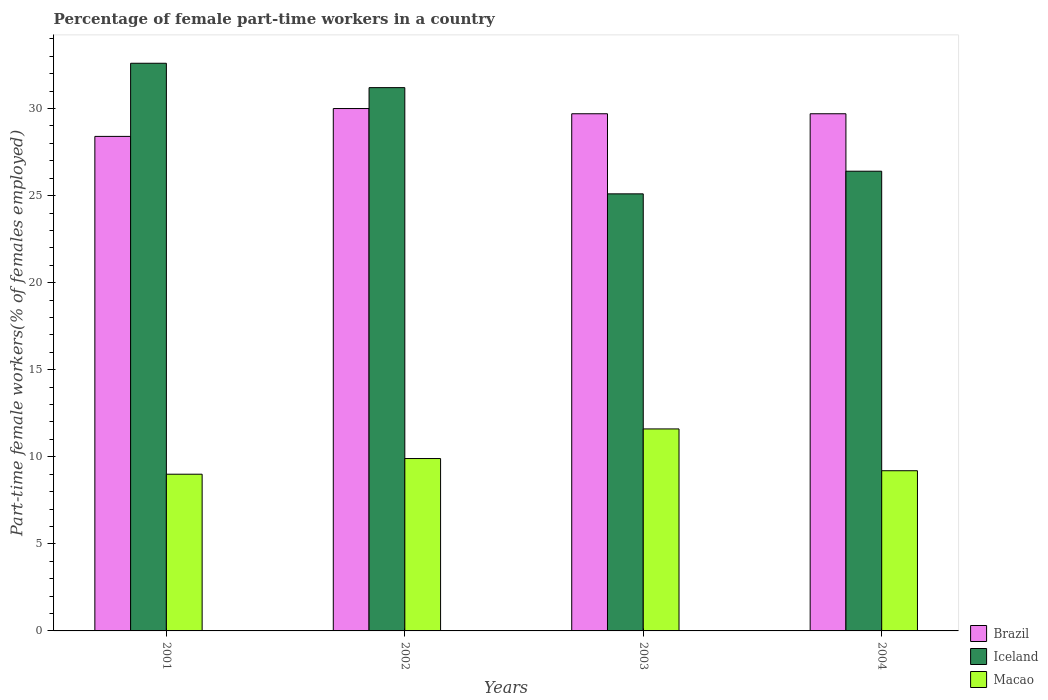How many groups of bars are there?
Make the answer very short. 4. Are the number of bars per tick equal to the number of legend labels?
Your answer should be compact. Yes. Are the number of bars on each tick of the X-axis equal?
Give a very brief answer. Yes. How many bars are there on the 1st tick from the left?
Provide a succinct answer. 3. What is the label of the 3rd group of bars from the left?
Keep it short and to the point. 2003. What is the percentage of female part-time workers in Macao in 2002?
Your response must be concise. 9.9. Across all years, what is the maximum percentage of female part-time workers in Iceland?
Your response must be concise. 32.6. Across all years, what is the minimum percentage of female part-time workers in Brazil?
Your answer should be compact. 28.4. In which year was the percentage of female part-time workers in Iceland maximum?
Keep it short and to the point. 2001. What is the total percentage of female part-time workers in Macao in the graph?
Give a very brief answer. 39.7. What is the difference between the percentage of female part-time workers in Macao in 2002 and the percentage of female part-time workers in Iceland in 2004?
Offer a terse response. -16.5. What is the average percentage of female part-time workers in Iceland per year?
Your answer should be very brief. 28.82. In the year 2003, what is the difference between the percentage of female part-time workers in Brazil and percentage of female part-time workers in Macao?
Keep it short and to the point. 18.1. In how many years, is the percentage of female part-time workers in Iceland greater than 24 %?
Provide a succinct answer. 4. What is the ratio of the percentage of female part-time workers in Brazil in 2002 to that in 2004?
Provide a succinct answer. 1.01. Is the percentage of female part-time workers in Brazil in 2002 less than that in 2004?
Your response must be concise. No. What is the difference between the highest and the second highest percentage of female part-time workers in Brazil?
Your answer should be compact. 0.3. What is the difference between the highest and the lowest percentage of female part-time workers in Brazil?
Give a very brief answer. 1.6. Is the sum of the percentage of female part-time workers in Brazil in 2002 and 2003 greater than the maximum percentage of female part-time workers in Iceland across all years?
Ensure brevity in your answer.  Yes. What does the 3rd bar from the left in 2001 represents?
Provide a succinct answer. Macao. What does the 1st bar from the right in 2001 represents?
Ensure brevity in your answer.  Macao. How many years are there in the graph?
Your response must be concise. 4. What is the difference between two consecutive major ticks on the Y-axis?
Keep it short and to the point. 5. Does the graph contain any zero values?
Your answer should be very brief. No. How many legend labels are there?
Offer a very short reply. 3. How are the legend labels stacked?
Keep it short and to the point. Vertical. What is the title of the graph?
Your answer should be very brief. Percentage of female part-time workers in a country. What is the label or title of the Y-axis?
Give a very brief answer. Part-time female workers(% of females employed). What is the Part-time female workers(% of females employed) in Brazil in 2001?
Your answer should be very brief. 28.4. What is the Part-time female workers(% of females employed) of Iceland in 2001?
Offer a terse response. 32.6. What is the Part-time female workers(% of females employed) of Macao in 2001?
Provide a succinct answer. 9. What is the Part-time female workers(% of females employed) of Brazil in 2002?
Offer a very short reply. 30. What is the Part-time female workers(% of females employed) in Iceland in 2002?
Offer a very short reply. 31.2. What is the Part-time female workers(% of females employed) of Macao in 2002?
Keep it short and to the point. 9.9. What is the Part-time female workers(% of females employed) of Brazil in 2003?
Keep it short and to the point. 29.7. What is the Part-time female workers(% of females employed) in Iceland in 2003?
Provide a short and direct response. 25.1. What is the Part-time female workers(% of females employed) of Macao in 2003?
Offer a very short reply. 11.6. What is the Part-time female workers(% of females employed) in Brazil in 2004?
Offer a terse response. 29.7. What is the Part-time female workers(% of females employed) in Iceland in 2004?
Make the answer very short. 26.4. What is the Part-time female workers(% of females employed) of Macao in 2004?
Keep it short and to the point. 9.2. Across all years, what is the maximum Part-time female workers(% of females employed) in Brazil?
Keep it short and to the point. 30. Across all years, what is the maximum Part-time female workers(% of females employed) in Iceland?
Your answer should be compact. 32.6. Across all years, what is the maximum Part-time female workers(% of females employed) of Macao?
Make the answer very short. 11.6. Across all years, what is the minimum Part-time female workers(% of females employed) of Brazil?
Ensure brevity in your answer.  28.4. Across all years, what is the minimum Part-time female workers(% of females employed) in Iceland?
Keep it short and to the point. 25.1. What is the total Part-time female workers(% of females employed) of Brazil in the graph?
Make the answer very short. 117.8. What is the total Part-time female workers(% of females employed) of Iceland in the graph?
Offer a terse response. 115.3. What is the total Part-time female workers(% of females employed) of Macao in the graph?
Your answer should be compact. 39.7. What is the difference between the Part-time female workers(% of females employed) of Brazil in 2001 and that in 2002?
Your answer should be compact. -1.6. What is the difference between the Part-time female workers(% of females employed) in Iceland in 2001 and that in 2002?
Your answer should be very brief. 1.4. What is the difference between the Part-time female workers(% of females employed) in Macao in 2001 and that in 2002?
Keep it short and to the point. -0.9. What is the difference between the Part-time female workers(% of females employed) of Brazil in 2001 and that in 2003?
Make the answer very short. -1.3. What is the difference between the Part-time female workers(% of females employed) in Iceland in 2001 and that in 2003?
Give a very brief answer. 7.5. What is the difference between the Part-time female workers(% of females employed) in Brazil in 2001 and that in 2004?
Make the answer very short. -1.3. What is the difference between the Part-time female workers(% of females employed) in Iceland in 2001 and that in 2004?
Ensure brevity in your answer.  6.2. What is the difference between the Part-time female workers(% of females employed) of Macao in 2001 and that in 2004?
Your answer should be compact. -0.2. What is the difference between the Part-time female workers(% of females employed) in Brazil in 2002 and that in 2003?
Your response must be concise. 0.3. What is the difference between the Part-time female workers(% of females employed) of Iceland in 2002 and that in 2003?
Provide a succinct answer. 6.1. What is the difference between the Part-time female workers(% of females employed) in Macao in 2002 and that in 2003?
Your answer should be very brief. -1.7. What is the difference between the Part-time female workers(% of females employed) in Brazil in 2003 and that in 2004?
Give a very brief answer. 0. What is the difference between the Part-time female workers(% of females employed) in Macao in 2003 and that in 2004?
Make the answer very short. 2.4. What is the difference between the Part-time female workers(% of females employed) in Brazil in 2001 and the Part-time female workers(% of females employed) in Iceland in 2002?
Keep it short and to the point. -2.8. What is the difference between the Part-time female workers(% of females employed) of Iceland in 2001 and the Part-time female workers(% of females employed) of Macao in 2002?
Ensure brevity in your answer.  22.7. What is the difference between the Part-time female workers(% of females employed) in Brazil in 2001 and the Part-time female workers(% of females employed) in Iceland in 2003?
Give a very brief answer. 3.3. What is the difference between the Part-time female workers(% of females employed) in Brazil in 2001 and the Part-time female workers(% of females employed) in Macao in 2003?
Your response must be concise. 16.8. What is the difference between the Part-time female workers(% of females employed) in Brazil in 2001 and the Part-time female workers(% of females employed) in Iceland in 2004?
Provide a short and direct response. 2. What is the difference between the Part-time female workers(% of females employed) in Brazil in 2001 and the Part-time female workers(% of females employed) in Macao in 2004?
Your answer should be very brief. 19.2. What is the difference between the Part-time female workers(% of females employed) of Iceland in 2001 and the Part-time female workers(% of females employed) of Macao in 2004?
Offer a very short reply. 23.4. What is the difference between the Part-time female workers(% of females employed) in Brazil in 2002 and the Part-time female workers(% of females employed) in Iceland in 2003?
Offer a very short reply. 4.9. What is the difference between the Part-time female workers(% of females employed) in Brazil in 2002 and the Part-time female workers(% of females employed) in Macao in 2003?
Keep it short and to the point. 18.4. What is the difference between the Part-time female workers(% of females employed) of Iceland in 2002 and the Part-time female workers(% of females employed) of Macao in 2003?
Your response must be concise. 19.6. What is the difference between the Part-time female workers(% of females employed) of Brazil in 2002 and the Part-time female workers(% of females employed) of Macao in 2004?
Your answer should be very brief. 20.8. What is the difference between the Part-time female workers(% of females employed) in Iceland in 2002 and the Part-time female workers(% of females employed) in Macao in 2004?
Your answer should be compact. 22. What is the difference between the Part-time female workers(% of females employed) of Brazil in 2003 and the Part-time female workers(% of females employed) of Macao in 2004?
Provide a short and direct response. 20.5. What is the difference between the Part-time female workers(% of females employed) of Iceland in 2003 and the Part-time female workers(% of females employed) of Macao in 2004?
Provide a succinct answer. 15.9. What is the average Part-time female workers(% of females employed) of Brazil per year?
Your response must be concise. 29.45. What is the average Part-time female workers(% of females employed) of Iceland per year?
Your answer should be compact. 28.82. What is the average Part-time female workers(% of females employed) of Macao per year?
Your answer should be compact. 9.93. In the year 2001, what is the difference between the Part-time female workers(% of females employed) in Iceland and Part-time female workers(% of females employed) in Macao?
Ensure brevity in your answer.  23.6. In the year 2002, what is the difference between the Part-time female workers(% of females employed) in Brazil and Part-time female workers(% of females employed) in Macao?
Provide a succinct answer. 20.1. In the year 2002, what is the difference between the Part-time female workers(% of females employed) in Iceland and Part-time female workers(% of females employed) in Macao?
Your answer should be very brief. 21.3. In the year 2003, what is the difference between the Part-time female workers(% of females employed) of Brazil and Part-time female workers(% of females employed) of Macao?
Offer a very short reply. 18.1. In the year 2003, what is the difference between the Part-time female workers(% of females employed) of Iceland and Part-time female workers(% of females employed) of Macao?
Your answer should be compact. 13.5. In the year 2004, what is the difference between the Part-time female workers(% of females employed) in Brazil and Part-time female workers(% of females employed) in Macao?
Keep it short and to the point. 20.5. In the year 2004, what is the difference between the Part-time female workers(% of females employed) of Iceland and Part-time female workers(% of females employed) of Macao?
Your response must be concise. 17.2. What is the ratio of the Part-time female workers(% of females employed) of Brazil in 2001 to that in 2002?
Give a very brief answer. 0.95. What is the ratio of the Part-time female workers(% of females employed) of Iceland in 2001 to that in 2002?
Your answer should be compact. 1.04. What is the ratio of the Part-time female workers(% of females employed) in Macao in 2001 to that in 2002?
Provide a short and direct response. 0.91. What is the ratio of the Part-time female workers(% of females employed) of Brazil in 2001 to that in 2003?
Ensure brevity in your answer.  0.96. What is the ratio of the Part-time female workers(% of females employed) of Iceland in 2001 to that in 2003?
Provide a short and direct response. 1.3. What is the ratio of the Part-time female workers(% of females employed) of Macao in 2001 to that in 2003?
Offer a very short reply. 0.78. What is the ratio of the Part-time female workers(% of females employed) in Brazil in 2001 to that in 2004?
Offer a terse response. 0.96. What is the ratio of the Part-time female workers(% of females employed) of Iceland in 2001 to that in 2004?
Offer a very short reply. 1.23. What is the ratio of the Part-time female workers(% of females employed) of Macao in 2001 to that in 2004?
Your answer should be very brief. 0.98. What is the ratio of the Part-time female workers(% of females employed) of Brazil in 2002 to that in 2003?
Keep it short and to the point. 1.01. What is the ratio of the Part-time female workers(% of females employed) in Iceland in 2002 to that in 2003?
Offer a very short reply. 1.24. What is the ratio of the Part-time female workers(% of females employed) of Macao in 2002 to that in 2003?
Keep it short and to the point. 0.85. What is the ratio of the Part-time female workers(% of females employed) in Iceland in 2002 to that in 2004?
Provide a short and direct response. 1.18. What is the ratio of the Part-time female workers(% of females employed) of Macao in 2002 to that in 2004?
Offer a terse response. 1.08. What is the ratio of the Part-time female workers(% of females employed) in Iceland in 2003 to that in 2004?
Offer a terse response. 0.95. What is the ratio of the Part-time female workers(% of females employed) of Macao in 2003 to that in 2004?
Provide a succinct answer. 1.26. What is the difference between the highest and the second highest Part-time female workers(% of females employed) in Macao?
Your response must be concise. 1.7. What is the difference between the highest and the lowest Part-time female workers(% of females employed) in Brazil?
Ensure brevity in your answer.  1.6. What is the difference between the highest and the lowest Part-time female workers(% of females employed) of Iceland?
Provide a short and direct response. 7.5. What is the difference between the highest and the lowest Part-time female workers(% of females employed) in Macao?
Provide a succinct answer. 2.6. 